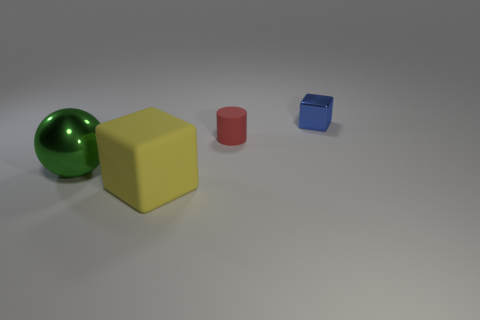Is there any other thing that is the same shape as the red matte object?
Ensure brevity in your answer.  No. How many big things are metallic objects or green matte blocks?
Give a very brief answer. 1. Is there any other thing of the same color as the big shiny ball?
Your answer should be compact. No. There is a blue object that is made of the same material as the big ball; what is its shape?
Your answer should be compact. Cube. There is a green shiny sphere that is left of the yellow block; what size is it?
Your answer should be very brief. Large. The yellow thing has what shape?
Offer a terse response. Cube. There is a matte object in front of the large green metallic thing; does it have the same size as the shiny object that is left of the small metallic cube?
Your answer should be very brief. Yes. There is a cube that is in front of the metallic object behind the matte thing that is behind the large green shiny thing; how big is it?
Your response must be concise. Large. What shape is the metal thing that is right of the metal thing left of the cube right of the tiny red thing?
Provide a succinct answer. Cube. The green metallic object in front of the tiny blue shiny object has what shape?
Your answer should be compact. Sphere. 